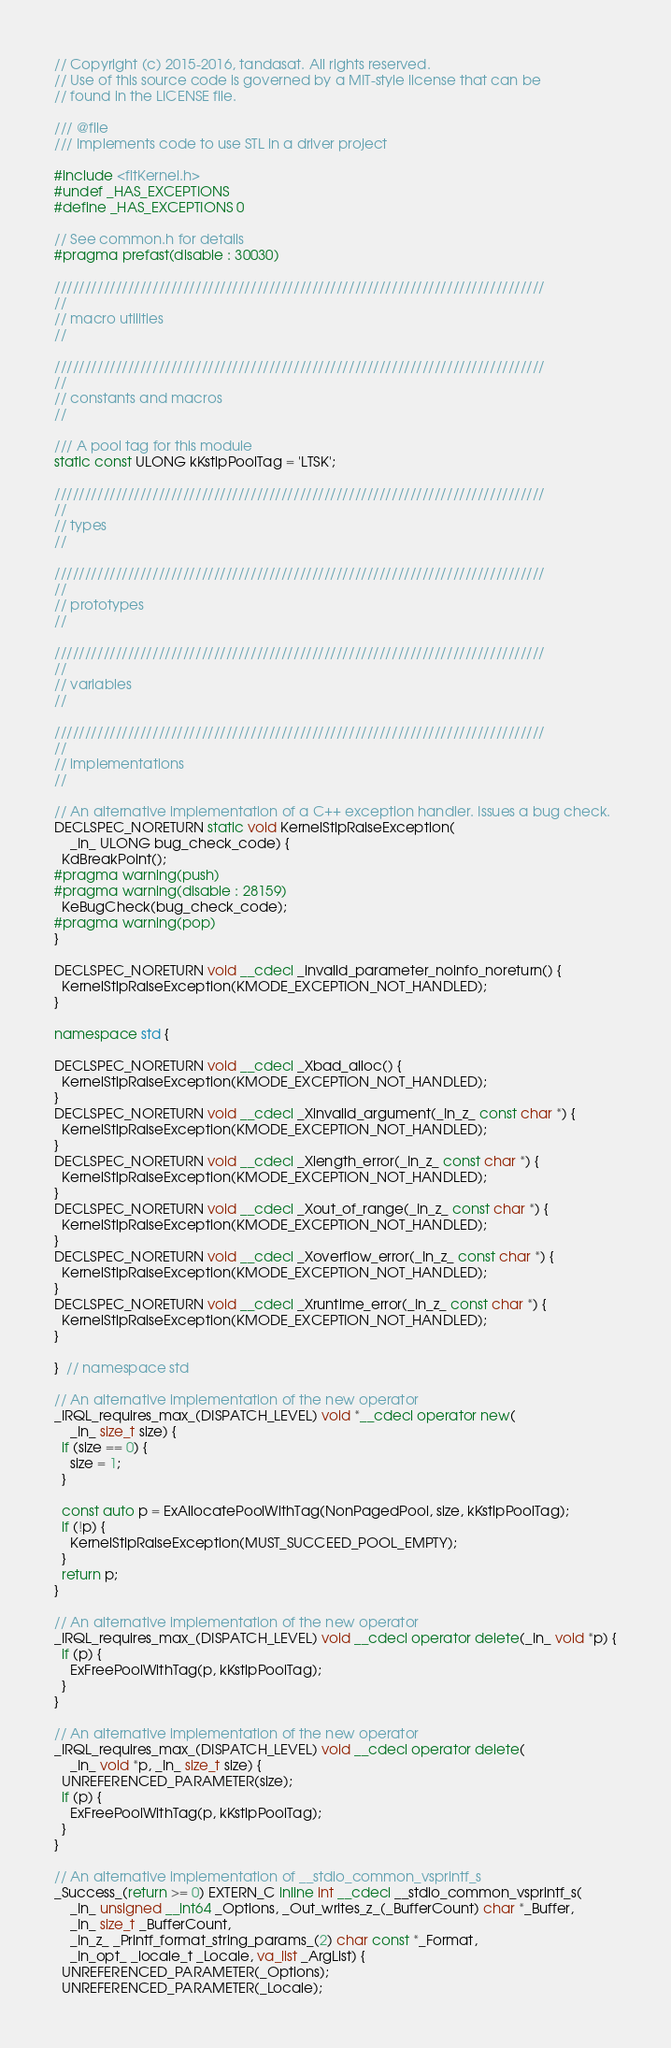<code> <loc_0><loc_0><loc_500><loc_500><_C++_>// Copyright (c) 2015-2016, tandasat. All rights reserved.
// Use of this source code is governed by a MIT-style license that can be
// found in the LICENSE file.

/// @file
/// Implements code to use STL in a driver project

#include <fltKernel.h>
#undef _HAS_EXCEPTIONS
#define _HAS_EXCEPTIONS 0

// See common.h for details
#pragma prefast(disable : 30030)

////////////////////////////////////////////////////////////////////////////////
//
// macro utilities
//

////////////////////////////////////////////////////////////////////////////////
//
// constants and macros
//

/// A pool tag for this module
static const ULONG kKstlpPoolTag = 'LTSK';

////////////////////////////////////////////////////////////////////////////////
//
// types
//

////////////////////////////////////////////////////////////////////////////////
//
// prototypes
//

////////////////////////////////////////////////////////////////////////////////
//
// variables
//

////////////////////////////////////////////////////////////////////////////////
//
// implementations
//

// An alternative implementation of a C++ exception handler. Issues a bug check.
DECLSPEC_NORETURN static void KernelStlpRaiseException(
    _In_ ULONG bug_check_code) {
  KdBreakPoint();
#pragma warning(push)
#pragma warning(disable : 28159)
  KeBugCheck(bug_check_code);
#pragma warning(pop)
}

DECLSPEC_NORETURN void __cdecl _invalid_parameter_noinfo_noreturn() {
  KernelStlpRaiseException(KMODE_EXCEPTION_NOT_HANDLED);
}

namespace std {

DECLSPEC_NORETURN void __cdecl _Xbad_alloc() {
  KernelStlpRaiseException(KMODE_EXCEPTION_NOT_HANDLED);
}
DECLSPEC_NORETURN void __cdecl _Xinvalid_argument(_In_z_ const char *) {
  KernelStlpRaiseException(KMODE_EXCEPTION_NOT_HANDLED);
}
DECLSPEC_NORETURN void __cdecl _Xlength_error(_In_z_ const char *) {
  KernelStlpRaiseException(KMODE_EXCEPTION_NOT_HANDLED);
}
DECLSPEC_NORETURN void __cdecl _Xout_of_range(_In_z_ const char *) {
  KernelStlpRaiseException(KMODE_EXCEPTION_NOT_HANDLED);
}
DECLSPEC_NORETURN void __cdecl _Xoverflow_error(_In_z_ const char *) {
  KernelStlpRaiseException(KMODE_EXCEPTION_NOT_HANDLED);
}
DECLSPEC_NORETURN void __cdecl _Xruntime_error(_In_z_ const char *) {
  KernelStlpRaiseException(KMODE_EXCEPTION_NOT_HANDLED);
}

}  // namespace std

// An alternative implementation of the new operator
_IRQL_requires_max_(DISPATCH_LEVEL) void *__cdecl operator new(
    _In_ size_t size) {
  if (size == 0) {
    size = 1;
  }

  const auto p = ExAllocatePoolWithTag(NonPagedPool, size, kKstlpPoolTag);
  if (!p) {
    KernelStlpRaiseException(MUST_SUCCEED_POOL_EMPTY);
  }
  return p;
}

// An alternative implementation of the new operator
_IRQL_requires_max_(DISPATCH_LEVEL) void __cdecl operator delete(_In_ void *p) {
  if (p) {
    ExFreePoolWithTag(p, kKstlpPoolTag);
  }
}

// An alternative implementation of the new operator
_IRQL_requires_max_(DISPATCH_LEVEL) void __cdecl operator delete(
    _In_ void *p, _In_ size_t size) {
  UNREFERENCED_PARAMETER(size);
  if (p) {
    ExFreePoolWithTag(p, kKstlpPoolTag);
  }
}

// An alternative implementation of __stdio_common_vsprintf_s
_Success_(return >= 0) EXTERN_C inline int __cdecl __stdio_common_vsprintf_s(
    _In_ unsigned __int64 _Options, _Out_writes_z_(_BufferCount) char *_Buffer,
    _In_ size_t _BufferCount,
    _In_z_ _Printf_format_string_params_(2) char const *_Format,
    _In_opt_ _locale_t _Locale, va_list _ArgList) {
  UNREFERENCED_PARAMETER(_Options);
  UNREFERENCED_PARAMETER(_Locale);
</code> 